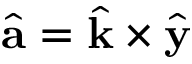<formula> <loc_0><loc_0><loc_500><loc_500>\hat { a } = \hat { k } \times \hat { y }</formula> 